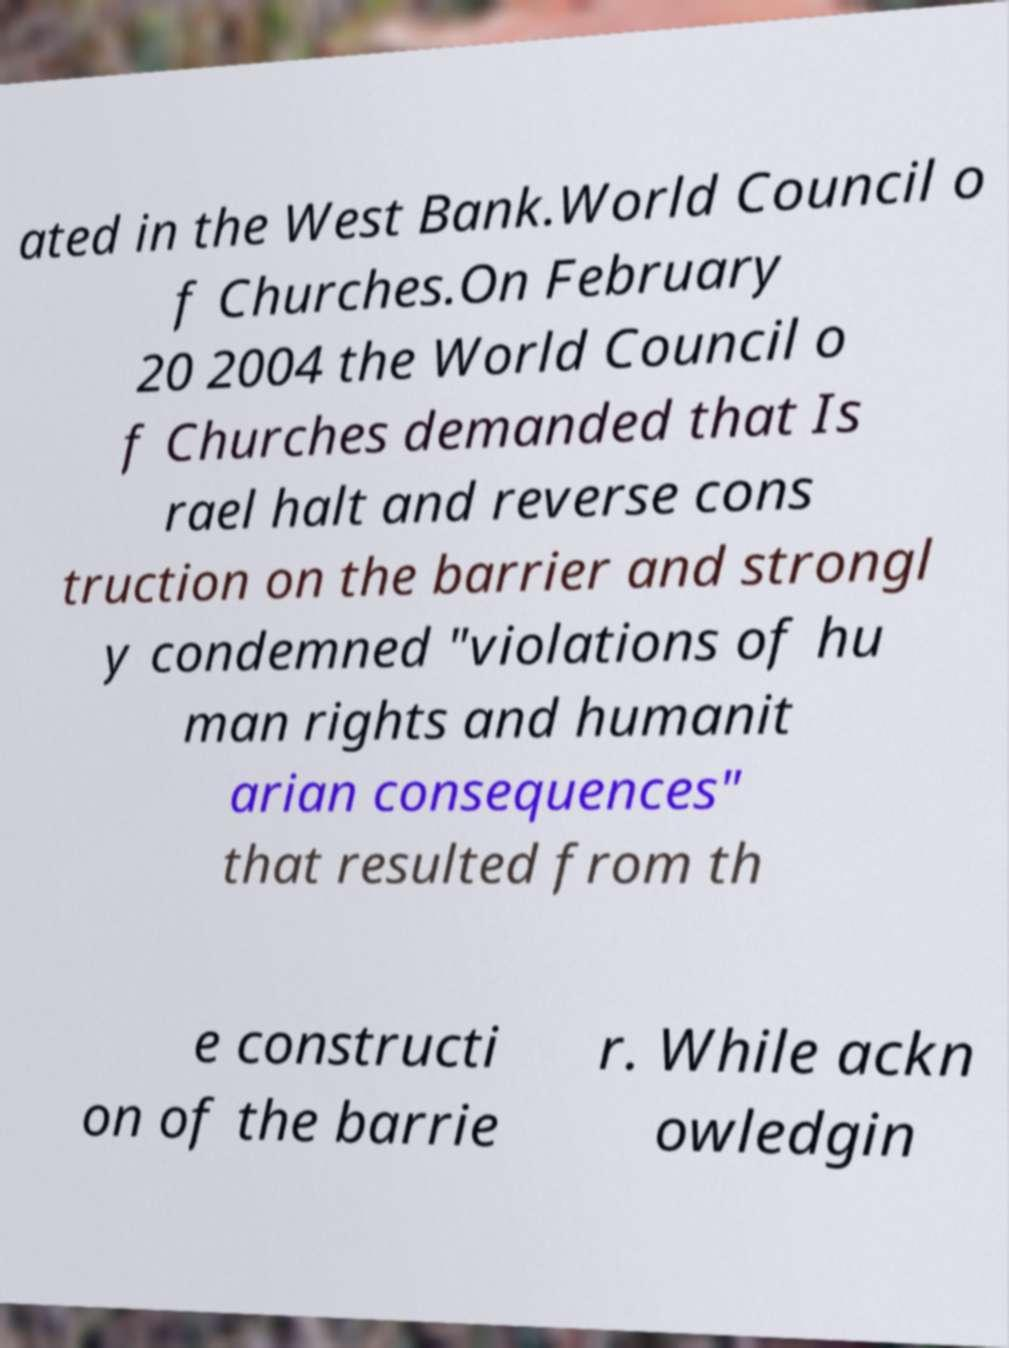Please identify and transcribe the text found in this image. ated in the West Bank.World Council o f Churches.On February 20 2004 the World Council o f Churches demanded that Is rael halt and reverse cons truction on the barrier and strongl y condemned "violations of hu man rights and humanit arian consequences" that resulted from th e constructi on of the barrie r. While ackn owledgin 